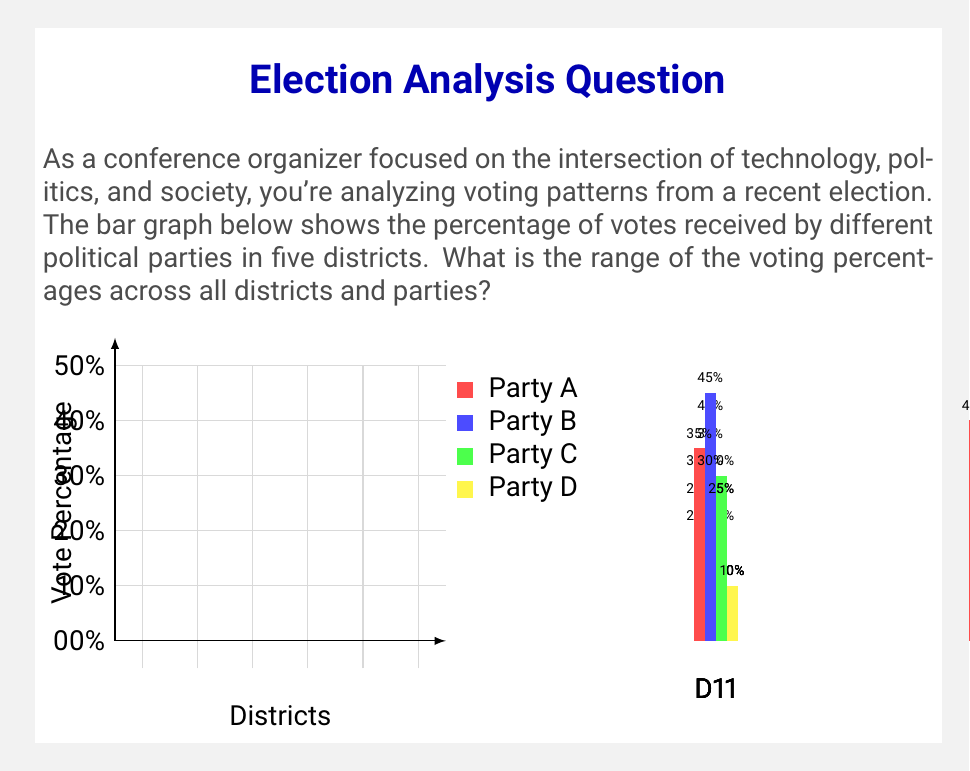Solve this math problem. To find the range of voting percentages, we need to identify the highest and lowest percentages in the entire dataset, then calculate the difference between them.

Step 1: Identify the highest percentage
Looking at all the bars in the graph, we can see that the highest percentage is 45% (Party B in District 3).

Step 2: Identify the lowest percentage
The lowest percentage visible in the graph is 10%, which appears multiple times (Party D in Districts 1, 2, 3, and 4).

Step 3: Calculate the range
The range is calculated by subtracting the minimum value from the maximum value:

$$ \text{Range} = \text{Maximum} - \text{Minimum} $$
$$ \text{Range} = 45\% - 10\% = 35\% $$

Therefore, the range of voting percentages across all districts and parties is 35 percentage points.
Answer: 35 percentage points 